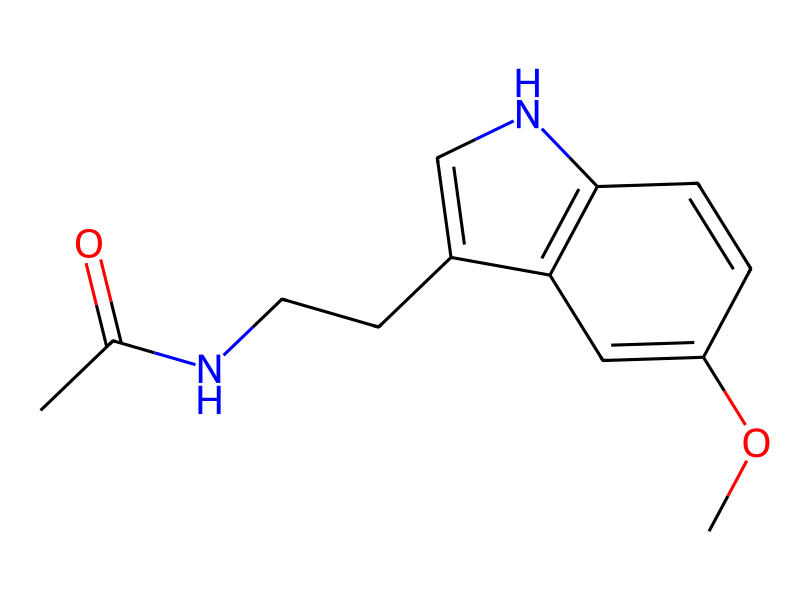What is the chemical name of the compound represented by this SMILES notation? The SMILES notation CC(=O)NCCC1=CNc2c1cc(OC)cc2 corresponds to the chemical known as melatonin, which is involved in sleep regulation.
Answer: melatonin How many carbon atoms are present in this molecule? By analyzing the SMILES notation, we can count the carbon atoms indicated by 'C' and 'c'. There are a total of 13 carbon atoms in the structure.
Answer: 13 What functional group is present in this molecule that indicates it might have a biological activity? The presence of the amide group (–C(=O)N–) within the structure indicates that this molecule may participate in interactions with biological receptors.
Answer: amide Which part of the molecule contributes to its aromatic properties? The molecule contains multiple 'c' atoms arranged in a cyclic structure (hydrocarbon ring), indicating the presence of aromatic properties.
Answer: aromatic ring What does the presence of the nitrogen atom indicate about the compound's classification? The nitrogen atom indicates that this compound is classified as a heterocyclic compound because it is part of a ring structure that includes atoms other than carbon.
Answer: heterocyclic Which atom is responsible for the compound's potential solubility in water? The presence of the nitrogen atom (as in amides or other polar functional groups) contributes to the overall polarity of the molecule, enhancing solubility in water.
Answer: nitrogen What is the total number of rings present in this compound? Upon examining the cyclic structures in the SMILES notation, we see there are two distinct rings, which indicates the presence of multiple rings within the molecule.
Answer: 2 